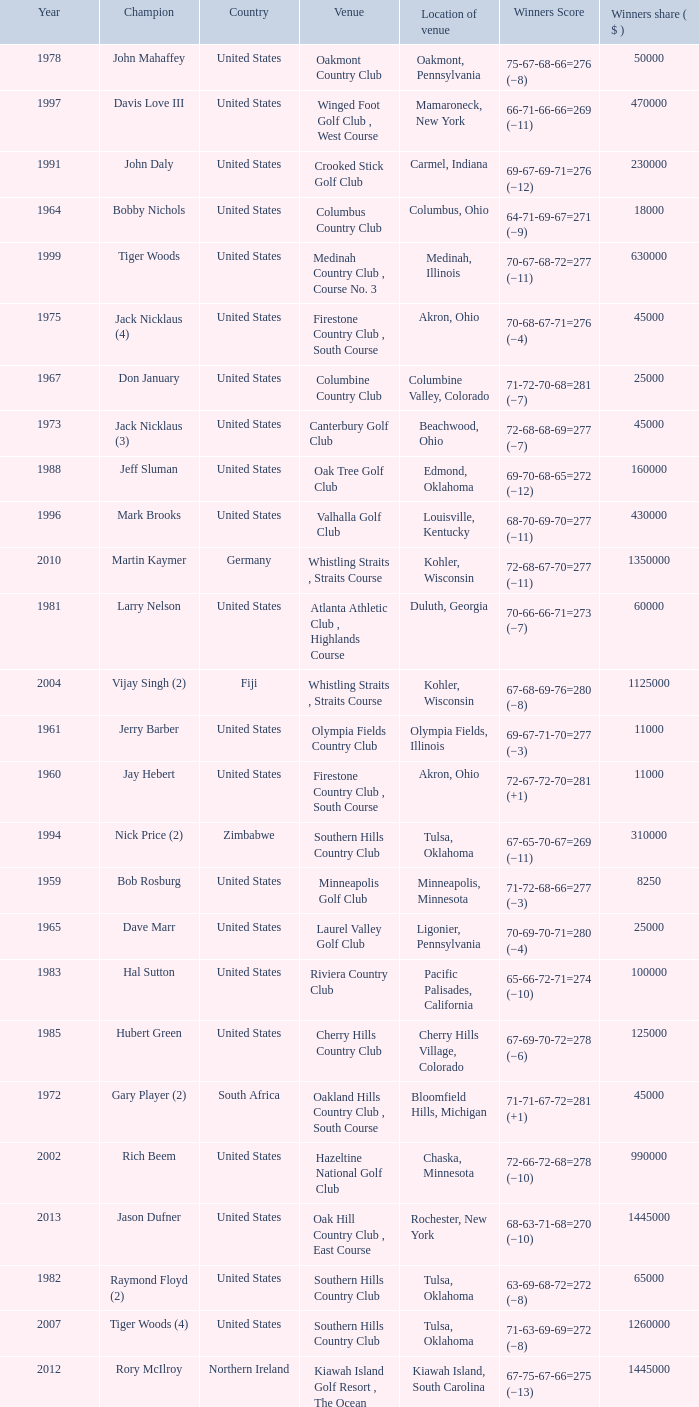I'm looking to parse the entire table for insights. Could you assist me with that? {'header': ['Year', 'Champion', 'Country', 'Venue', 'Location of venue', 'Winners Score', 'Winners share ( $ )'], 'rows': [['1978', 'John Mahaffey', 'United States', 'Oakmont Country Club', 'Oakmont, Pennsylvania', '75-67-68-66=276 (−8)', '50000'], ['1997', 'Davis Love III', 'United States', 'Winged Foot Golf Club , West Course', 'Mamaroneck, New York', '66-71-66-66=269 (−11)', '470000'], ['1991', 'John Daly', 'United States', 'Crooked Stick Golf Club', 'Carmel, Indiana', '69-67-69-71=276 (−12)', '230000'], ['1964', 'Bobby Nichols', 'United States', 'Columbus Country Club', 'Columbus, Ohio', '64-71-69-67=271 (−9)', '18000'], ['1999', 'Tiger Woods', 'United States', 'Medinah Country Club , Course No. 3', 'Medinah, Illinois', '70-67-68-72=277 (−11)', '630000'], ['1975', 'Jack Nicklaus (4)', 'United States', 'Firestone Country Club , South Course', 'Akron, Ohio', '70-68-67-71=276 (−4)', '45000'], ['1967', 'Don January', 'United States', 'Columbine Country Club', 'Columbine Valley, Colorado', '71-72-70-68=281 (−7)', '25000'], ['1973', 'Jack Nicklaus (3)', 'United States', 'Canterbury Golf Club', 'Beachwood, Ohio', '72-68-68-69=277 (−7)', '45000'], ['1988', 'Jeff Sluman', 'United States', 'Oak Tree Golf Club', 'Edmond, Oklahoma', '69-70-68-65=272 (−12)', '160000'], ['1996', 'Mark Brooks', 'United States', 'Valhalla Golf Club', 'Louisville, Kentucky', '68-70-69-70=277 (−11)', '430000'], ['2010', 'Martin Kaymer', 'Germany', 'Whistling Straits , Straits Course', 'Kohler, Wisconsin', '72-68-67-70=277 (−11)', '1350000'], ['1981', 'Larry Nelson', 'United States', 'Atlanta Athletic Club , Highlands Course', 'Duluth, Georgia', '70-66-66-71=273 (−7)', '60000'], ['2004', 'Vijay Singh (2)', 'Fiji', 'Whistling Straits , Straits Course', 'Kohler, Wisconsin', '67-68-69-76=280 (−8)', '1125000'], ['1961', 'Jerry Barber', 'United States', 'Olympia Fields Country Club', 'Olympia Fields, Illinois', '69-67-71-70=277 (−3)', '11000'], ['1960', 'Jay Hebert', 'United States', 'Firestone Country Club , South Course', 'Akron, Ohio', '72-67-72-70=281 (+1)', '11000'], ['1994', 'Nick Price (2)', 'Zimbabwe', 'Southern Hills Country Club', 'Tulsa, Oklahoma', '67-65-70-67=269 (−11)', '310000'], ['1959', 'Bob Rosburg', 'United States', 'Minneapolis Golf Club', 'Minneapolis, Minnesota', '71-72-68-66=277 (−3)', '8250'], ['1965', 'Dave Marr', 'United States', 'Laurel Valley Golf Club', 'Ligonier, Pennsylvania', '70-69-70-71=280 (−4)', '25000'], ['1983', 'Hal Sutton', 'United States', 'Riviera Country Club', 'Pacific Palisades, California', '65-66-72-71=274 (−10)', '100000'], ['1985', 'Hubert Green', 'United States', 'Cherry Hills Country Club', 'Cherry Hills Village, Colorado', '67-69-70-72=278 (−6)', '125000'], ['1972', 'Gary Player (2)', 'South Africa', 'Oakland Hills Country Club , South Course', 'Bloomfield Hills, Michigan', '71-71-67-72=281 (+1)', '45000'], ['2002', 'Rich Beem', 'United States', 'Hazeltine National Golf Club', 'Chaska, Minnesota', '72-66-72-68=278 (−10)', '990000'], ['2013', 'Jason Dufner', 'United States', 'Oak Hill Country Club , East Course', 'Rochester, New York', '68-63-71-68=270 (−10)', '1445000'], ['1982', 'Raymond Floyd (2)', 'United States', 'Southern Hills Country Club', 'Tulsa, Oklahoma', '63-69-68-72=272 (−8)', '65000'], ['2007', 'Tiger Woods (4)', 'United States', 'Southern Hills Country Club', 'Tulsa, Oklahoma', '71-63-69-69=272 (−8)', '1260000'], ['2012', 'Rory McIlroy', 'Northern Ireland', 'Kiawah Island Golf Resort , The Ocean Course', 'Kiawah Island, South Carolina', '67-75-67-66=275 (−13)', '1445000'], ['1979', 'David Graham', 'Australia', 'Oakland Hills Country Club , South Course', 'Bloomfield Township, Michigan', '69-68-70-65=272 (−8)', '60000'], ['1995', 'Steve Elkington', 'Australia', 'Riviera Country Club', 'Pacific Palisades, California', '68-67-68-64=267 (−17)', '360000'], ['1993', 'Paul Azinger', 'United States', 'Inverness Club', 'Toledo, Ohio', '69-66-69-68=272 (−12)', '300000'], ['1980', 'Jack Nicklaus (5)', 'United States', 'Oak Hill Country Club , East Course', 'Rochester, New York', '70-69-66-69=274 (−6)', '60000'], ['2006', 'Tiger Woods (3)', 'United States', 'Medinah Country Club , Course No. 3', 'Medinah, Illinois', '69-68-65-68=270 (−18)', '1224000'], ['1966', 'Al Geiberger', 'United States', 'Firestone Country Club , South Course', 'Akron, Ohio', '68-72-68-72=280 (E)', '25000'], ['1989', 'Payne Stewart', 'United States', 'Kemper Lakes Golf Club', 'Long Grove, Illinois', '74-66-69-67=276 (−12)', '200000'], ['1990', 'Wayne Grady', 'Australia', 'Shoal Creek Golf and Country Club', 'Birmingham, Alabama', '72-67-72-71=282 (−6)', '225000'], ['1976', 'Dave Stockton (2)', 'United States', 'Congressional Country Club , Blue Course', 'Bethesda, Maryland', '70-72-69-70=281 (+1)', '45000'], ['2009', 'Yang Yong-eun', 'South Korea', 'Hazeltine National Golf Club', 'Chaska, Minnesota', '73-70-67-70=280 (−8)', '1350000'], ['1963', 'Jack Nicklaus', 'United States', 'Dallas Athletic Club , Blue Course', 'Dallas, Texas', '69-73-69-68=279 (−5)', '13000'], ['2001', 'David Toms', 'United States', 'Atlanta Athletic Club , Highlands Course', 'Duluth, Georgia', '66-65-65-69=265 (−15)', '936000'], ['1987', 'Larry Nelson (2)', 'United States', 'PGA National Resort & Spa', 'Palm Beach Gardens, Florida', '70-72-73-72=287 (−1)', '150000'], ['2008', 'Pádraig Harrington', 'Ireland', 'Oakland Hills Country Club , South Course', 'Bloomfield Township, Michigan', '71-74-66-66=277 (−3)', '1350000'], ['1992', 'Nick Price', 'Zimbabwe', 'Bellerive Country Club', 'St. Louis, Missouri', '70-70-68-70=278 (−6)', '280000'], ['1968', 'Julius Boros', 'United States', 'Pecan Valley Golf Club', 'San Antonio, Texas', '71-71-70-69=281 (+1)', '25000'], ['2005', 'Phil Mickelson', 'United States', 'Baltusrol Golf Club , Lower Course', 'Springfield, New Jersey', '67-65-72-72=276 (−4)', '1170000'], ['1969', 'Raymond Floyd', 'United States', 'NCR Country Club , South Course', 'Dayton, Ohio', '69-66-67-74=276 (−8)', '35000'], ['1984', 'Lee Trevino (2)', 'United States', 'Shoal Creek Golf and Country Club', 'Birmingham, Alabama', '69-68-67-69=273 (−15)', '125000'], ['1970', 'Dave Stockton', 'United States', 'Southern Hills Country Club', 'Tulsa, Oklahoma', '70-70-66-73=279 (−1)', '40000'], ['1986', 'Bob Tway', 'United States', 'Inverness Club', 'Toledo, Ohio', '72-70-64-70=276 (−8)', '145000'], ['2003', 'Shaun Micheel', 'United States', 'Oak Hill Country Club , East Course', 'Rochester, New York', '69-68-69-70=276 (−4)', '1080000'], ['1977', 'Lanny Wadkins', 'United States', 'Pebble Beach Golf Links', 'Pebble Beach, California', '69-71-72-70=282 (−6)', '45000'], ['1998', 'Vijay Singh', 'Fiji', 'Sahalee Country Club', 'Sammamish, Washington', '70-66-67-68=271 (−9)', '540000'], ['2011', 'Keegan Bradley', 'United States', 'Atlanta Athletic Club , Highlands Course', 'Johns Creek, Georgia', '71-64-69-68=272 (−8)', '1445000'], ['1974', 'Lee Trevino', 'United States', 'Tanglewood Park , Championship Course', 'Clemmons, North Carolina', '73-66-68-69=276 (−4)', '45000'], ['2000', 'Tiger Woods (2)', 'United States', 'Valhalla Golf Club', 'Louisville, Kentucky', '66-67-70-67=270 (−18)', '900000'], ['1971', 'Jack Nicklaus (2)', 'United States', 'PGA National Golf Club', 'Palm Beach Gardens, Florida', '69-69-70-73=281 (−7)', '40000'], ['1962', 'Gary Player', 'South Africa', 'Aronimink Golf Club', 'Newtown Square, Pennsylvania', '72-67-69-70=278 (−2)', '13000']]} Where is the Bellerive Country Club venue located? St. Louis, Missouri. 